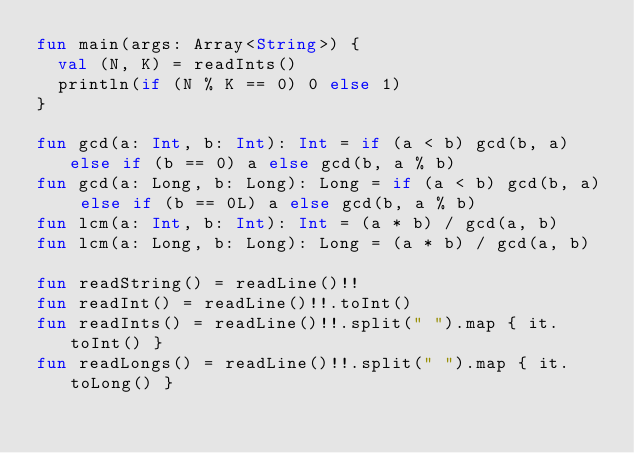Convert code to text. <code><loc_0><loc_0><loc_500><loc_500><_Kotlin_>fun main(args: Array<String>) {
  val (N, K) = readInts()
  println(if (N % K == 0) 0 else 1)
}

fun gcd(a: Int, b: Int): Int = if (a < b) gcd(b, a) else if (b == 0) a else gcd(b, a % b)
fun gcd(a: Long, b: Long): Long = if (a < b) gcd(b, a) else if (b == 0L) a else gcd(b, a % b)
fun lcm(a: Int, b: Int): Int = (a * b) / gcd(a, b)
fun lcm(a: Long, b: Long): Long = (a * b) / gcd(a, b)

fun readString() = readLine()!!
fun readInt() = readLine()!!.toInt()
fun readInts() = readLine()!!.split(" ").map { it.toInt() }
fun readLongs() = readLine()!!.split(" ").map { it.toLong() }
</code> 